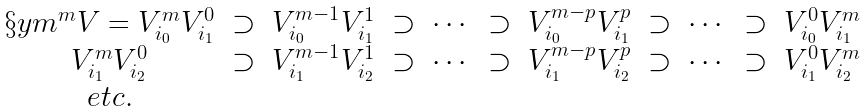<formula> <loc_0><loc_0><loc_500><loc_500>\begin{array} { c c c c c c c c c c c } \S y m ^ { m } V = V _ { i _ { 0 } } ^ { m } V _ { i _ { 1 } } ^ { 0 } & \supset & V _ { i _ { 0 } } ^ { m - 1 } V _ { i _ { 1 } } ^ { 1 } & \supset & \cdots & \supset & V _ { i _ { 0 } } ^ { m - p } V _ { i _ { 1 } } ^ { p } & \supset & \cdots & \supset & V _ { i _ { 0 } } ^ { 0 } V _ { i _ { 1 } } ^ { m } \\ V _ { i _ { 1 } } ^ { m } V _ { i _ { 2 } } ^ { 0 } & \supset & V _ { i _ { 1 } } ^ { m - 1 } V _ { i _ { 2 } } ^ { 1 } & \supset & \cdots & \supset & V _ { i _ { 1 } } ^ { m - p } V _ { i _ { 2 } } ^ { p } & \supset & \cdots & \supset & V _ { i _ { 1 } } ^ { 0 } V _ { i _ { 2 } } ^ { m } \\ e t c . \end{array}</formula> 